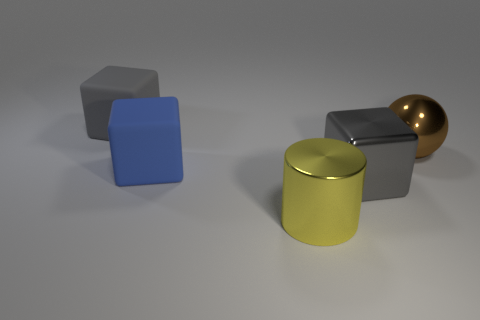Can you describe the lighting and mood of the scene? The lighting in the scene is soft and diffused, with shadows indicating light coming from above. The mood is neutral and calm, emphasized by the muted colors and simple background. 